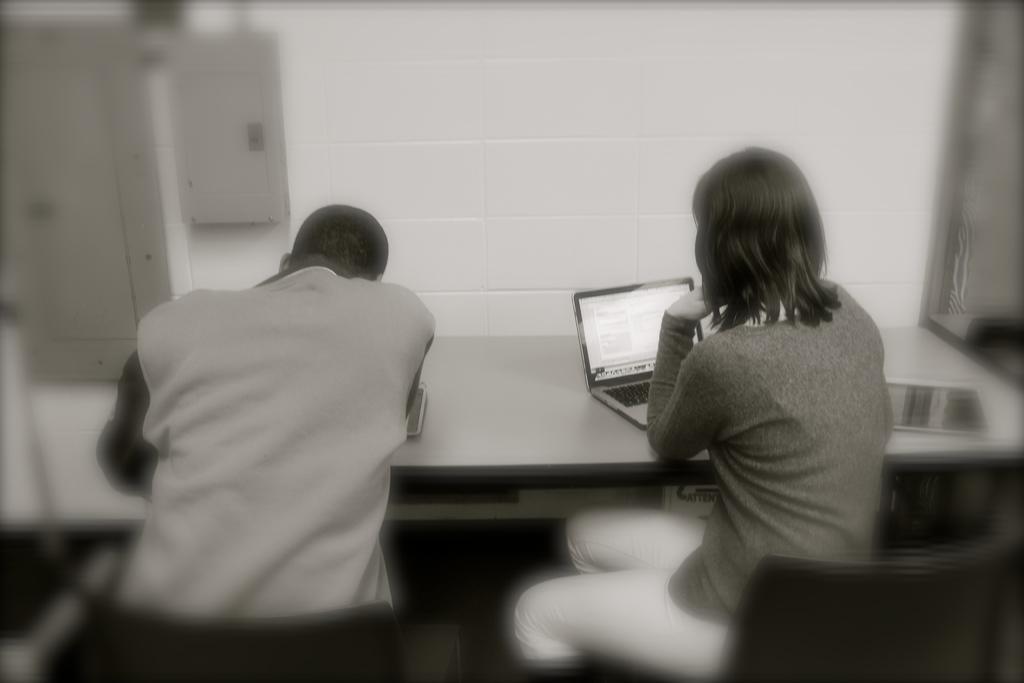Can you describe this image briefly? In the given image on the right hand side i can see a lady using a laptop and on the left hand side i can see a person bending on the bench. 